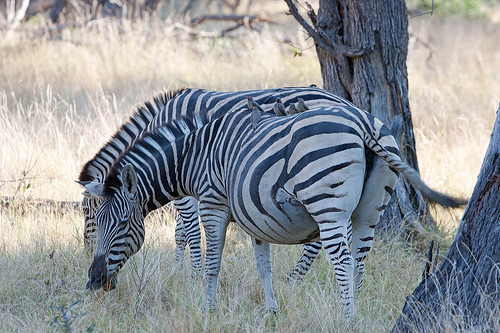How many zebras are there? 2 